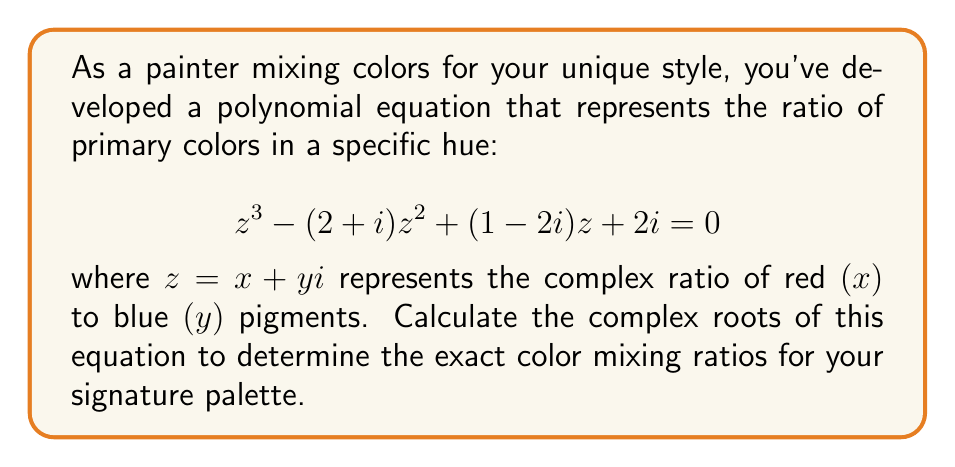Can you solve this math problem? To solve this cubic equation, we can use the following steps:

1) First, we need to identify the coefficients:
   $a = 1$
   $b = -(2+i)$
   $c = 1-2i$
   $d = 2i$

2) Calculate the intermediate values:
   $p = \frac{3ac-b^2}{3a^2} = \frac{3(1)(1-2i) - (-2-i)^2}{3(1)^2} = \frac{3-6i - (4+4i+i^2)}{3} = \frac{-1-10i}{3}$
   
   $q = \frac{2b^3-9abc+27a^2d}{27a^3} = \frac{2(-2-i)^3 - 9(1)(-2-i)(1-2i) + 27(1)^2(2i)}{27(1)^3}$
   $= \frac{-8-12i+6i-i^3 + 18+9i-36i+18i^2 + 54i}{27} = \frac{10+14i}{27}$

3) Calculate the discriminant:
   $D = (\frac{q}{2})^2 + (\frac{p}{3})^3 = (\frac{5+7i}{27})^2 + (\frac{-1-10i}{9})^3$

4) Calculate the cube roots:
   $u = \sqrt[3]{-\frac{q}{2} + \sqrt{D}}$
   $v = \sqrt[3]{-\frac{q}{2} - \sqrt{D}}$

5) The three roots are given by:
   $z_1 = u + v - \frac{b}{3a}$
   $z_2 = \omega u + \omega^2 v - \frac{b}{3a}$
   $z_3 = \omega^2 u + \omega v - \frac{b}{3a}$

   where $\omega = -\frac{1}{2} + i\frac{\sqrt{3}}{2}$ is a cube root of unity.

6) Substitute the values and simplify to get the final roots.
Answer: The three complex roots are approximately:

$z_1 \approx 2.2071 + 0.3660i$
$z_2 \approx -0.1036 + 0.8170i$
$z_3 \approx -0.1036 - 0.1830i$

These roots represent the ratios of red to blue pigments in your signature color palette. 